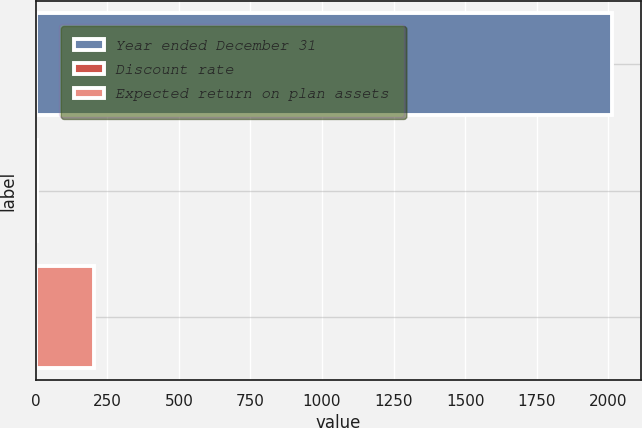Convert chart to OTSL. <chart><loc_0><loc_0><loc_500><loc_500><bar_chart><fcel>Year ended December 31<fcel>Discount rate<fcel>Expected return on plan assets<nl><fcel>2012<fcel>4<fcel>204.8<nl></chart> 